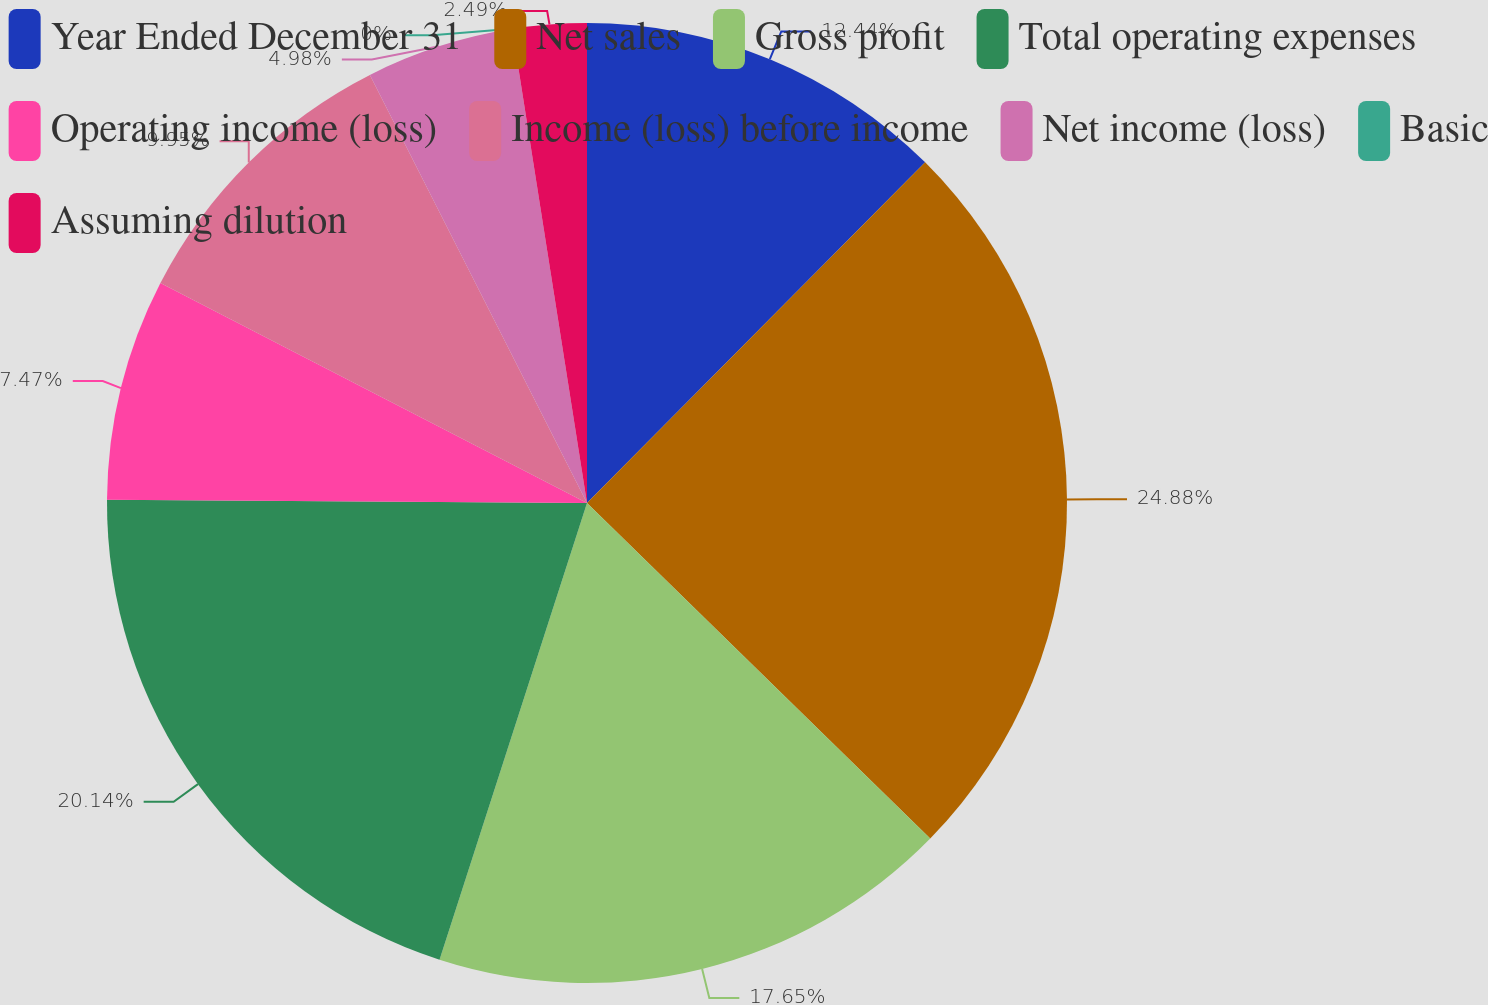Convert chart. <chart><loc_0><loc_0><loc_500><loc_500><pie_chart><fcel>Year Ended December 31<fcel>Net sales<fcel>Gross profit<fcel>Total operating expenses<fcel>Operating income (loss)<fcel>Income (loss) before income<fcel>Net income (loss)<fcel>Basic<fcel>Assuming dilution<nl><fcel>12.44%<fcel>24.88%<fcel>17.65%<fcel>20.14%<fcel>7.47%<fcel>9.95%<fcel>4.98%<fcel>0.0%<fcel>2.49%<nl></chart> 